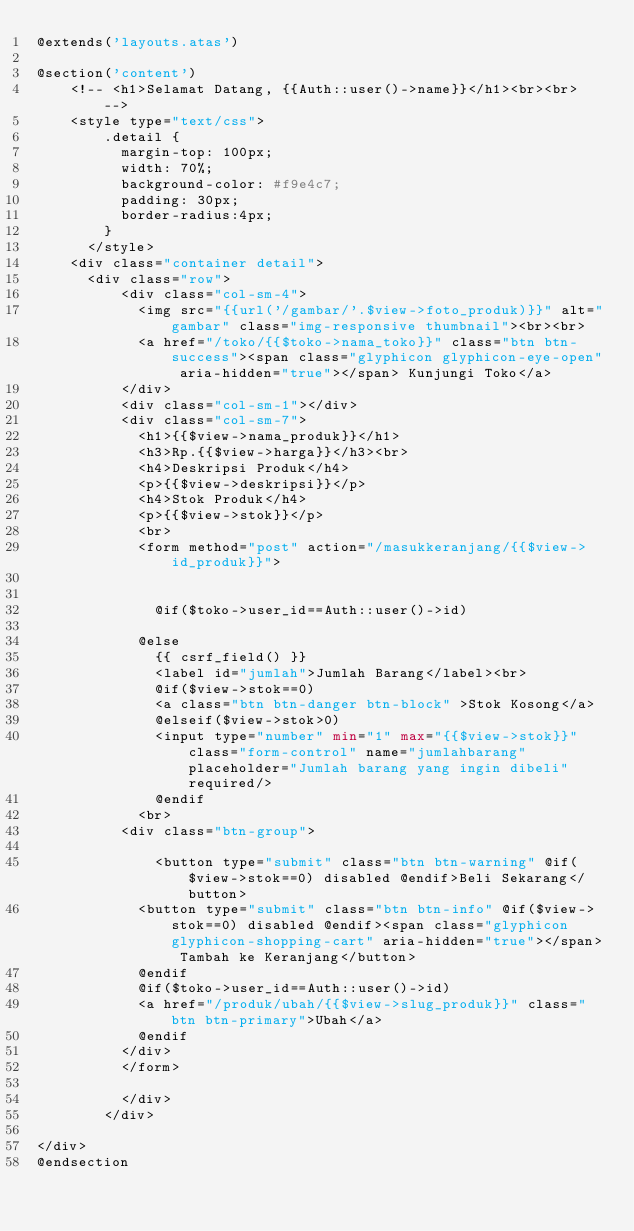<code> <loc_0><loc_0><loc_500><loc_500><_PHP_>@extends('layouts.atas')

@section('content')
    <!-- <h1>Selamat Datang, {{Auth::user()->name}}</h1><br><br> -->
    <style type="text/css">
      	.detail {
      		margin-top: 100px;
      		width: 70%;
      		background-color: #f9e4c7;
      		padding: 30px;
          border-radius:4px;
      	}
      </style>
    <div class="container detail">
      <div class="row">
      		<div class="col-sm-4">
      			<img src="{{url('/gambar/'.$view->foto_produk)}}" alt="gambar" class="img-responsive thumbnail"><br><br>
      			<a href="/toko/{{$toko->nama_toko}}" class="btn btn-success"><span class="glyphicon glyphicon-eye-open" aria-hidden="true"></span> Kunjungi Toko</a>
      		</div>
      		<div class="col-sm-1"></div>
      		<div class="col-sm-7">
      			<h1>{{$view->nama_produk}}</h1>
      			<h3>Rp.{{$view->harga}}</h3><br>
      			<h4>Deskripsi Produk</h4>
      			<p>{{$view->deskripsi}}</p>
            <h4>Stok Produk</h4>
      			<p>{{$view->stok}}</p>
      			<br>
            <form method="post" action="/masukkeranjang/{{$view->id_produk}}">

             
              @if($toko->user_id==Auth::user()->id)

            @else
              {{ csrf_field() }}
      				<label id="jumlah">Jumlah Barang</label><br>
              @if($view->stok==0)
              <a class="btn btn-danger btn-block" >Stok Kosong</a>
              @elseif($view->stok>0)
              <input type="number" min="1" max="{{$view->stok}}" class="form-control" name="jumlahbarang" placeholder="Jumlah barang yang ingin dibeli" required/>
              @endif
      			<br>
      		<div class="btn-group">

        			<button type="submit" class="btn btn-warning" @if($view->stok==0) disabled @endif>Beli Sekarang</button>
      			<button type="submit" class="btn btn-info" @if($view->stok==0) disabled @endif><span class="glyphicon glyphicon-shopping-cart" aria-hidden="true"></span> Tambah ke Keranjang</button>
            @endif
            @if($toko->user_id==Auth::user()->id)
            <a href="/produk/ubah/{{$view->slug_produk}}" class="btn btn-primary">Ubah</a>
            @endif
      		</div>
          </form>

      		</div>
      	</div>

</div>
@endsection
</code> 